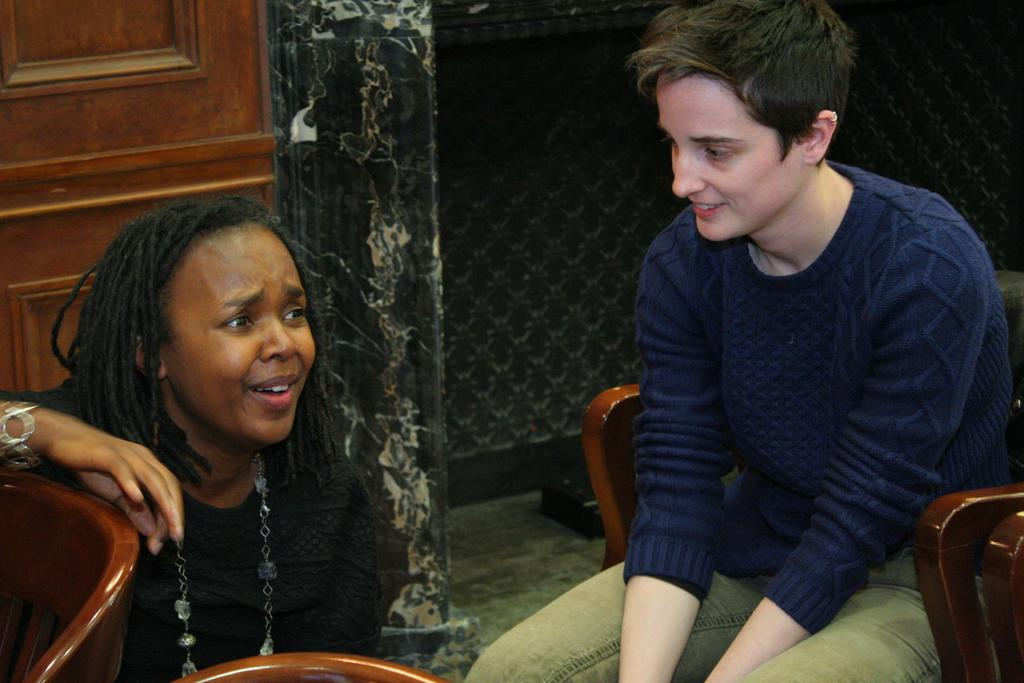How many people are in the image? There are two people in the image. What objects are present that might be used for sitting? There are chairs in the image. What type of fruit is being tasted by the people in the image? There is no fruit present in the image, and the people's actions are not described. 